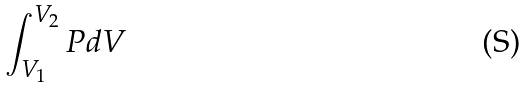<formula> <loc_0><loc_0><loc_500><loc_500>\int _ { V _ { 1 } } ^ { V _ { 2 } } P d V</formula> 